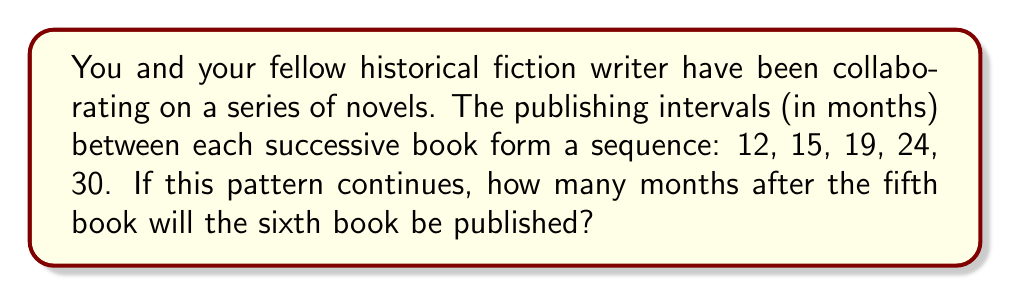Teach me how to tackle this problem. To solve this problem, we need to identify the pattern in the sequence of publishing intervals:

1. First, calculate the differences between consecutive terms:
   $12 \rightarrow 15$ (difference: 3)
   $15 \rightarrow 19$ (difference: 4)
   $19 \rightarrow 24$ (difference: 5)
   $24 \rightarrow 30$ (difference: 6)

2. We can see that the difference between consecutive terms is increasing by 1 each time:
   3, 4, 5, 6

3. This suggests that the sequence follows a quadratic pattern.

4. To find the next term, we need to add the next difference, which would be 7, to the last term:

   $30 + 7 = 37$

5. Therefore, the sixth book will be published 37 months after the fifth book.

This can be verified by fitting a quadratic function to the sequence:

Let $a_n$ be the $n$th term of the sequence.
$a_n = an^2 + bn + c$

Solving the system of equations:
$a(1)^2 + b(1) + c = 12$
$a(2)^2 + b(2) + c = 15$
$a(3)^2 + b(3) + c = 19$

We get: $a_n = \frac{1}{2}n^2 + \frac{5}{2}n + 9$

For $n = 6$: $a_6 = \frac{1}{2}(6)^2 + \frac{5}{2}(6) + 9 = 37$
Answer: 37 months 